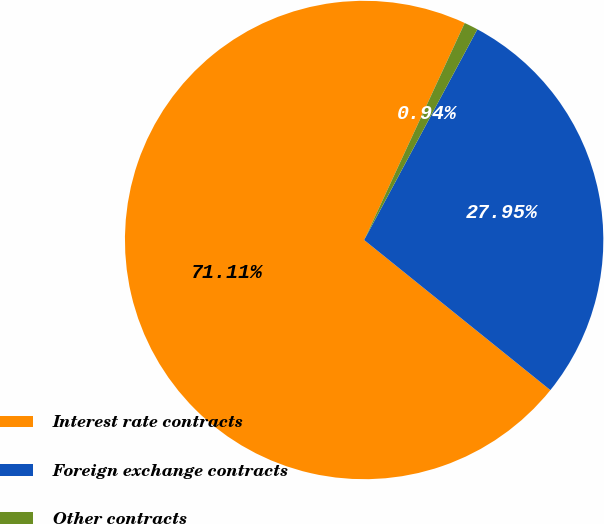<chart> <loc_0><loc_0><loc_500><loc_500><pie_chart><fcel>Interest rate contracts<fcel>Foreign exchange contracts<fcel>Other contracts<nl><fcel>71.11%<fcel>27.95%<fcel>0.94%<nl></chart> 